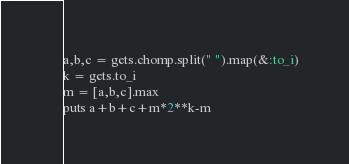<code> <loc_0><loc_0><loc_500><loc_500><_Ruby_>a,b,c = gets.chomp.split(" ").map(&:to_i)
k = gets.to_i
m = [a,b,c].max
puts a+b+c+m*2**k-m</code> 